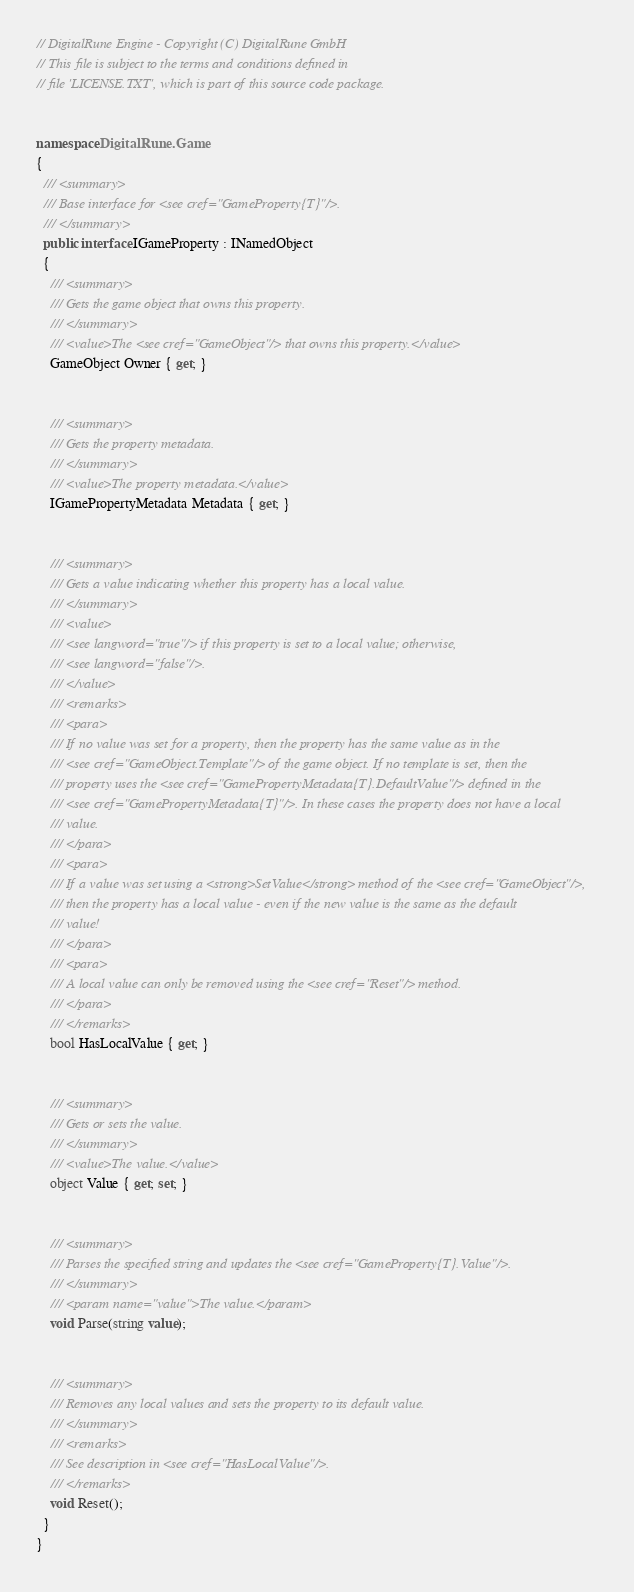Convert code to text. <code><loc_0><loc_0><loc_500><loc_500><_C#_>// DigitalRune Engine - Copyright (C) DigitalRune GmbH
// This file is subject to the terms and conditions defined in
// file 'LICENSE.TXT', which is part of this source code package.


namespace DigitalRune.Game
{
  /// <summary>
  /// Base interface for <see cref="GameProperty{T}"/>.
  /// </summary>
  public interface IGameProperty : INamedObject
  {
    /// <summary>
    /// Gets the game object that owns this property.
    /// </summary>
    /// <value>The <see cref="GameObject"/> that owns this property.</value>
    GameObject Owner { get; }


    /// <summary>
    /// Gets the property metadata.
    /// </summary>
    /// <value>The property metadata.</value>
    IGamePropertyMetadata Metadata { get; }


    /// <summary>
    /// Gets a value indicating whether this property has a local value.
    /// </summary>
    /// <value>
    /// <see langword="true"/> if this property is set to a local value; otherwise, 
    /// <see langword="false"/>.
    /// </value>
    /// <remarks>
    /// <para>
    /// If no value was set for a property, then the property has the same value as in the 
    /// <see cref="GameObject.Template"/> of the game object. If no template is set, then the
    /// property uses the <see cref="GamePropertyMetadata{T}.DefaultValue"/> defined in the 
    /// <see cref="GamePropertyMetadata{T}"/>. In these cases the property does not have a local
    /// value.
    /// </para>
    /// <para>
    /// If a value was set using a <strong>SetValue</strong> method of the <see cref="GameObject"/>,
    /// then the property has a local value - even if the new value is the same as the default 
    /// value!
    /// </para>
    /// <para>
    /// A local value can only be removed using the <see cref="Reset"/> method.
    /// </para>
    /// </remarks>
    bool HasLocalValue { get; }


    /// <summary>
    /// Gets or sets the value.
    /// </summary>
    /// <value>The value.</value>
    object Value { get; set; }

    
    /// <summary>
    /// Parses the specified string and updates the <see cref="GameProperty{T}.Value"/>.
    /// </summary>
    /// <param name="value">The value.</param>
    void Parse(string value);


    /// <summary>
    /// Removes any local values and sets the property to its default value.
    /// </summary>
    /// <remarks>
    /// See description in <see cref="HasLocalValue"/>.
    /// </remarks>
    void Reset();
  }
}
</code> 